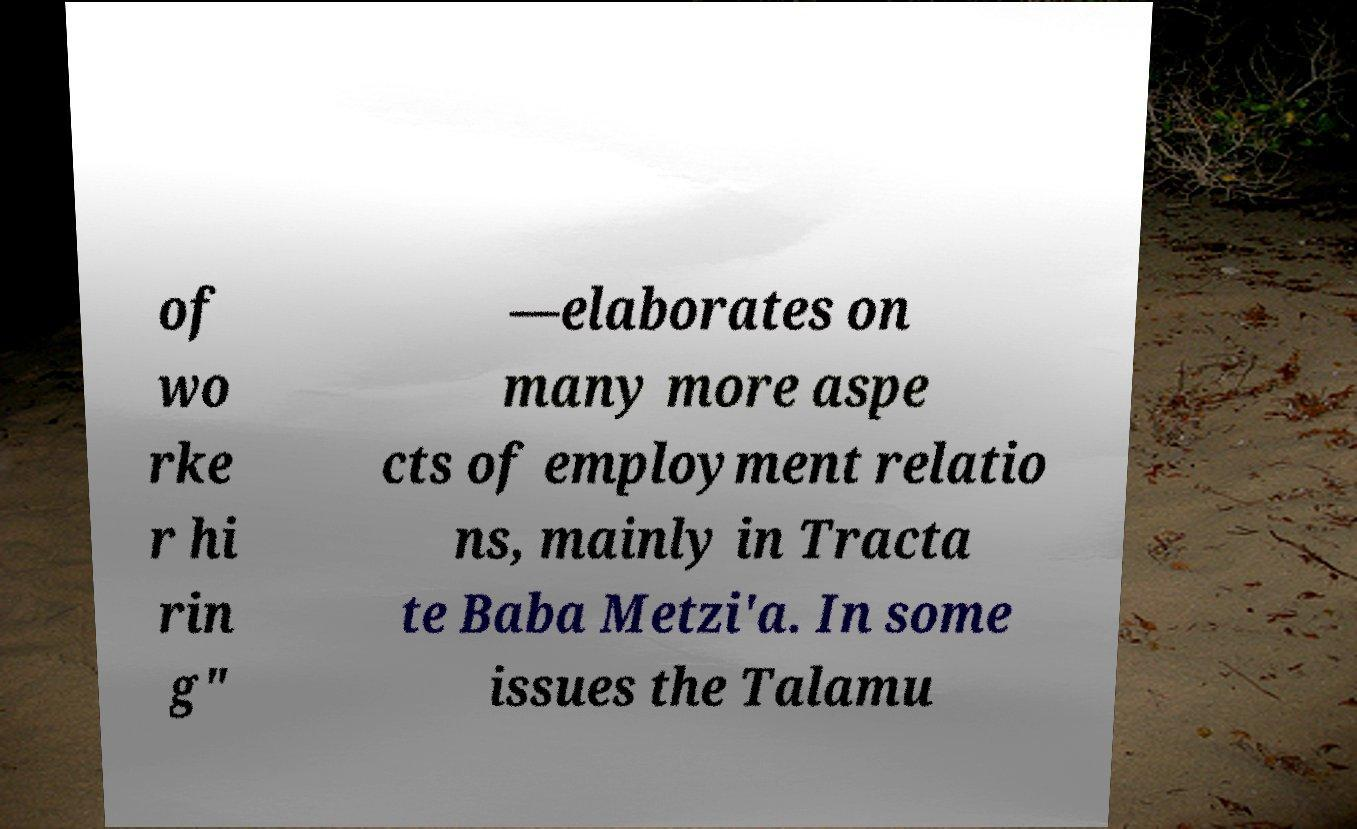For documentation purposes, I need the text within this image transcribed. Could you provide that? of wo rke r hi rin g" —elaborates on many more aspe cts of employment relatio ns, mainly in Tracta te Baba Metzi'a. In some issues the Talamu 